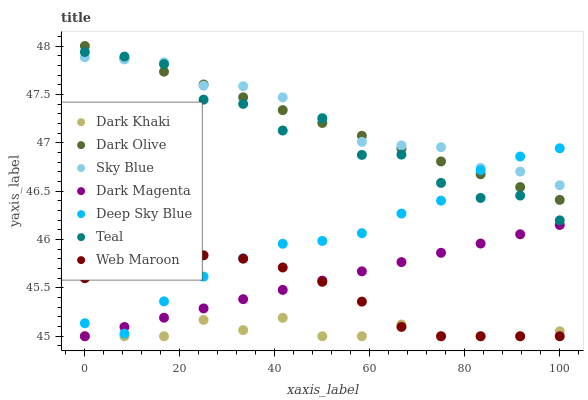Does Dark Khaki have the minimum area under the curve?
Answer yes or no. Yes. Does Sky Blue have the maximum area under the curve?
Answer yes or no. Yes. Does Dark Olive have the minimum area under the curve?
Answer yes or no. No. Does Dark Olive have the maximum area under the curve?
Answer yes or no. No. Is Dark Magenta the smoothest?
Answer yes or no. Yes. Is Teal the roughest?
Answer yes or no. Yes. Is Dark Olive the smoothest?
Answer yes or no. No. Is Dark Olive the roughest?
Answer yes or no. No. Does Dark Magenta have the lowest value?
Answer yes or no. Yes. Does Dark Olive have the lowest value?
Answer yes or no. No. Does Dark Olive have the highest value?
Answer yes or no. Yes. Does Web Maroon have the highest value?
Answer yes or no. No. Is Dark Khaki less than Deep Sky Blue?
Answer yes or no. Yes. Is Sky Blue greater than Dark Khaki?
Answer yes or no. Yes. Does Dark Khaki intersect Dark Magenta?
Answer yes or no. Yes. Is Dark Khaki less than Dark Magenta?
Answer yes or no. No. Is Dark Khaki greater than Dark Magenta?
Answer yes or no. No. Does Dark Khaki intersect Deep Sky Blue?
Answer yes or no. No. 